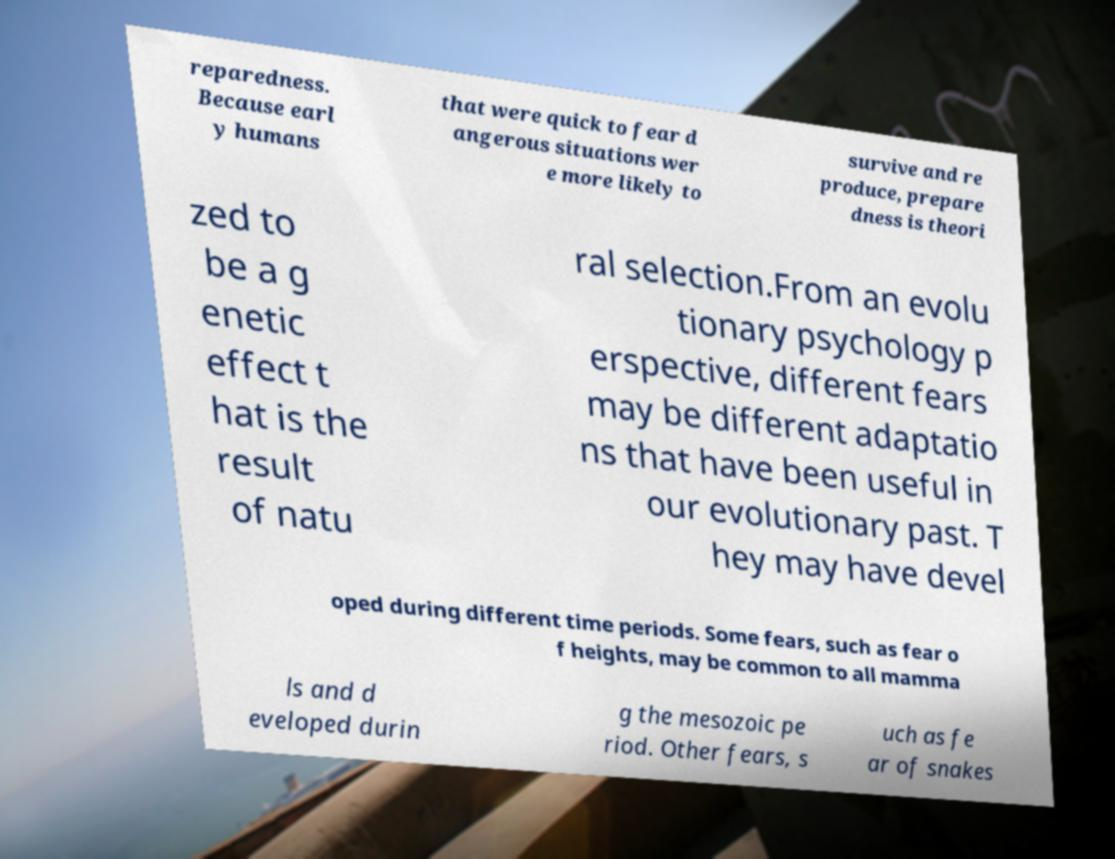What messages or text are displayed in this image? I need them in a readable, typed format. reparedness. Because earl y humans that were quick to fear d angerous situations wer e more likely to survive and re produce, prepare dness is theori zed to be a g enetic effect t hat is the result of natu ral selection.From an evolu tionary psychology p erspective, different fears may be different adaptatio ns that have been useful in our evolutionary past. T hey may have devel oped during different time periods. Some fears, such as fear o f heights, may be common to all mamma ls and d eveloped durin g the mesozoic pe riod. Other fears, s uch as fe ar of snakes 